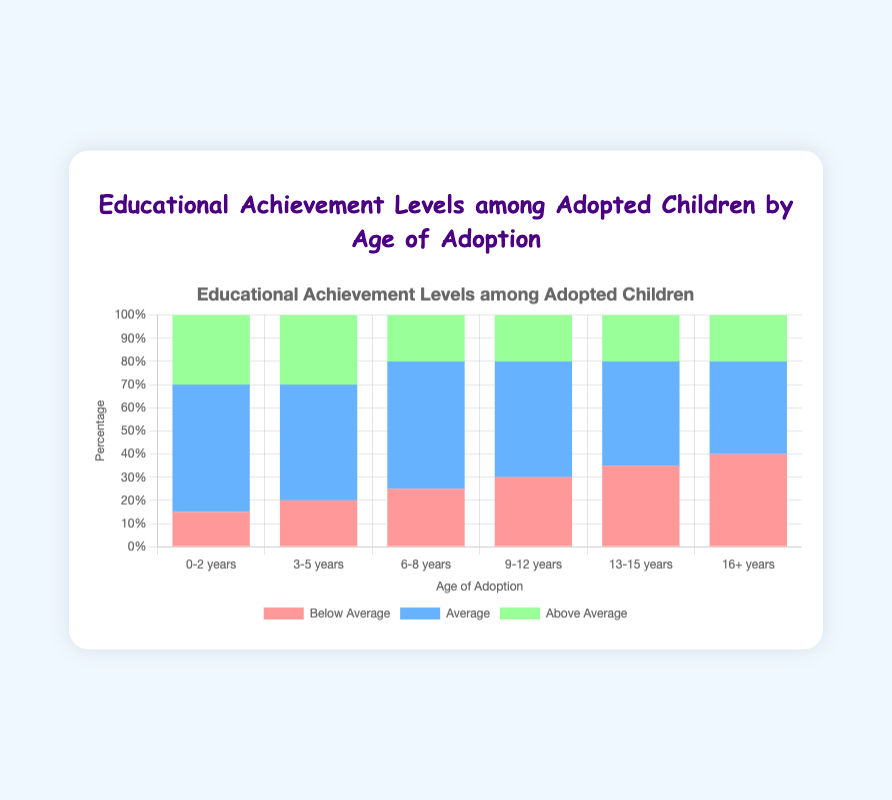What age group of adopted children has the highest percentage of children with Below Average educational achievement? By looking at the heights of the red bars, we can see the "16+ years" group has the tallest red bar at 40%.
Answer: "16+ years" Which age group of adopted children has the lowest percentage of children with Above Average educational achievement? By comparing the heights of the green bars, each age group from "6-8 years" to "16+ years" has an equal height for the green bar at 20%, which is the lowest. However, "16+ years" also has 20%. Hence, "6-8 years", "9-12 years", "13-15 years", and "16+ years" all have the lowest percentage.
Answer: "6-8 years", "9-12 years", "13-15 years", "16+ years" What is the total percentage of Average educational achievement for the age groups "0-2 years" and "3-5 years" combined? We need to add the percentages for Average from both age groups: 55% (for 0-2 years) + 50% (for 3-5 years) = 105%
Answer: 105% Is the percentage of Below Average educational achievement higher for children adopted at "9-12 years" than for those adopted at "3-5 years"? The red bar for "9-12 years" is at 30%, while the red bar for "3-5 years" is at 20%, so yes, it is higher for the "9-12 years" group.
Answer: Yes For children adopted at "6-8 years", what is the difference in percentage points between Below Average and Above Average educational achievement? Subtract the percentage of Above Average (20%) from Below Average (25%): 25% - 20% = 5%
Answer: 5% Which age group has the smallest spread (difference) between the Below Average and Above Average educational achievement percentages? Calculate spreads: 
- 0-2 years: 15% to 30% = 15%
- 3-5 years: 20% to 30% = 10%
- 6-8 years: 25% to 20% = 5%
- 9-12 years: 30% to 20% = 10%
- 13-15 years: 35% to 20% = 15%
- 16+ years: 40% to 20% = 20%
The smallest spread is for the "6-8 years" group, which is 5%.
Answer: "6-8 years" For the age group "0-2 years," what are the visual attributes for each educational achievement level in terms of color? The educational achievement levels for "0-2 years" are as follows:
- Below Average: Red
- Average: Blue
- Above Average: Green
Answer: Red, Blue, Green 